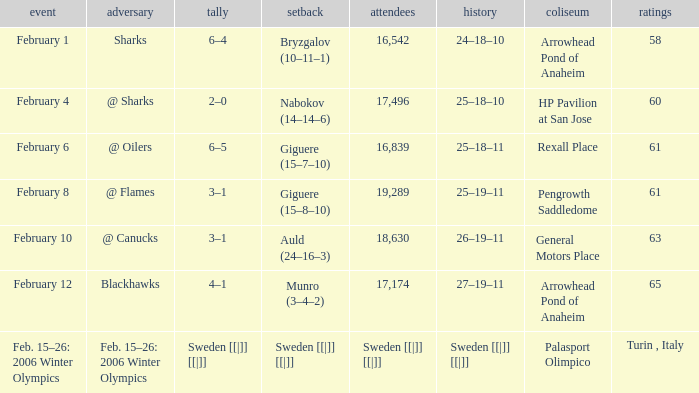What is the record at Arrowhead Pond of Anaheim, when the loss was Bryzgalov (10–11–1)? 24–18–10. 